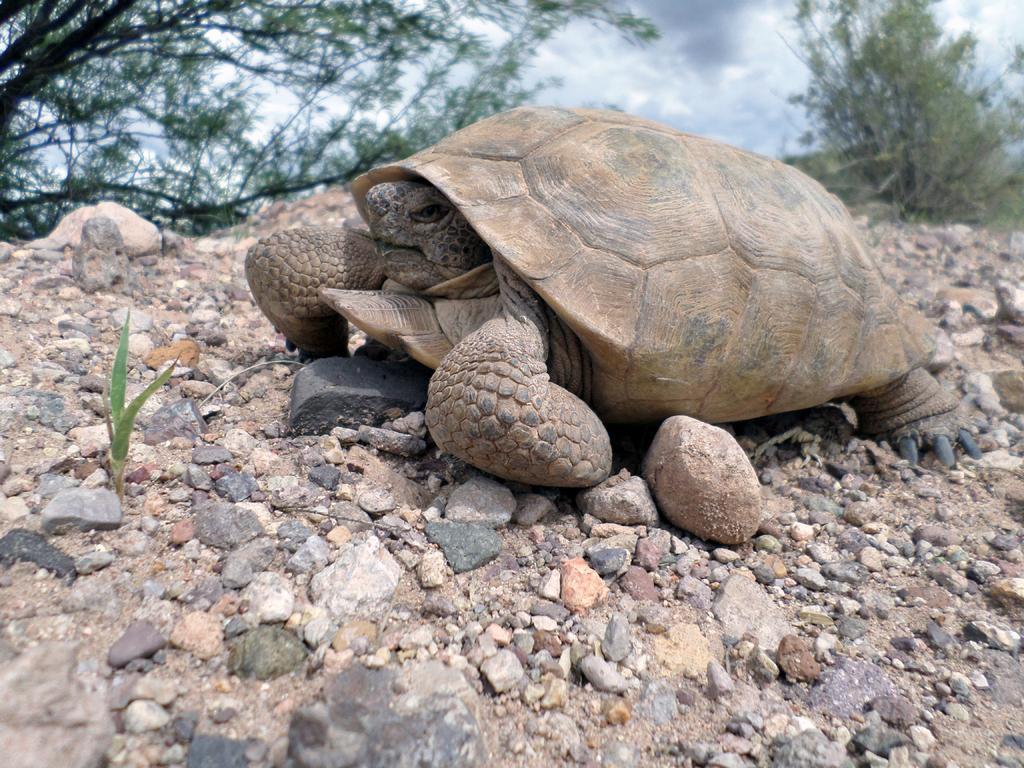In one or two sentences, can you explain what this image depicts? In this image we can see one tortoise on the ground, some rocks on the ground, one plant, some trees and grass on the ground. In the background there is the cloudy sky. 